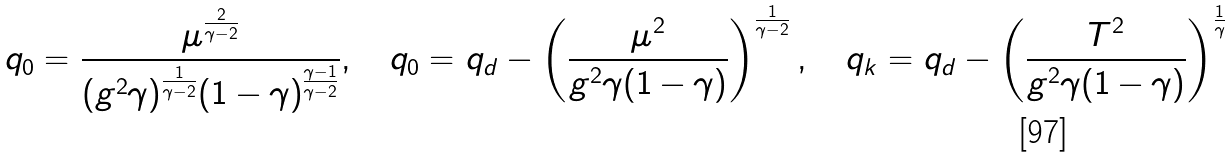Convert formula to latex. <formula><loc_0><loc_0><loc_500><loc_500>q _ { 0 } = \frac { \mu ^ { \frac { 2 } { \gamma - 2 } } } { ( g ^ { 2 } \gamma ) ^ { \frac { 1 } { \gamma - 2 } } ( 1 - \gamma ) ^ { \frac { \gamma - 1 } { \gamma - 2 } } } , \quad q _ { 0 } = q _ { d } - \left ( \frac { \mu ^ { 2 } } { g ^ { 2 } \gamma ( 1 - \gamma ) } \right ) ^ { \frac { 1 } { \gamma - 2 } } , \quad q _ { k } = q _ { d } - \left ( \frac { T ^ { 2 } } { g ^ { 2 } \gamma ( 1 - \gamma ) } \right ) ^ { \frac { 1 } { \gamma } }</formula> 